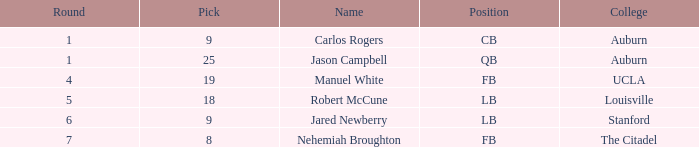Which educational institution had a combined pick of 9? Auburn. 